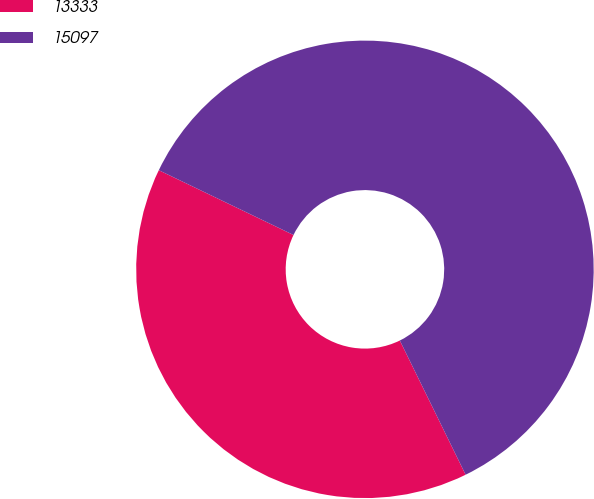Convert chart. <chart><loc_0><loc_0><loc_500><loc_500><pie_chart><fcel>13333<fcel>15097<nl><fcel>39.39%<fcel>60.61%<nl></chart> 